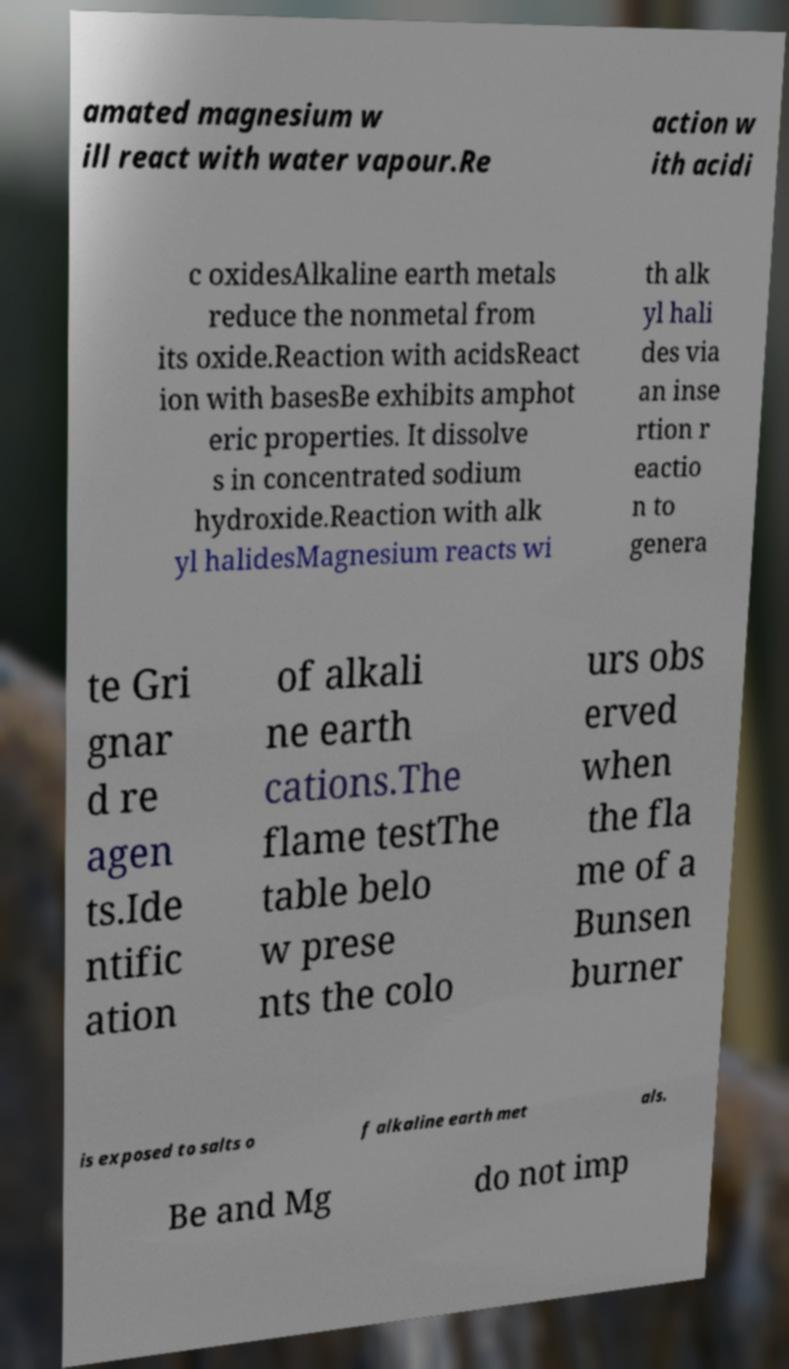I need the written content from this picture converted into text. Can you do that? amated magnesium w ill react with water vapour.Re action w ith acidi c oxidesAlkaline earth metals reduce the nonmetal from its oxide.Reaction with acidsReact ion with basesBe exhibits amphot eric properties. It dissolve s in concentrated sodium hydroxide.Reaction with alk yl halidesMagnesium reacts wi th alk yl hali des via an inse rtion r eactio n to genera te Gri gnar d re agen ts.Ide ntific ation of alkali ne earth cations.The flame testThe table belo w prese nts the colo urs obs erved when the fla me of a Bunsen burner is exposed to salts o f alkaline earth met als. Be and Mg do not imp 